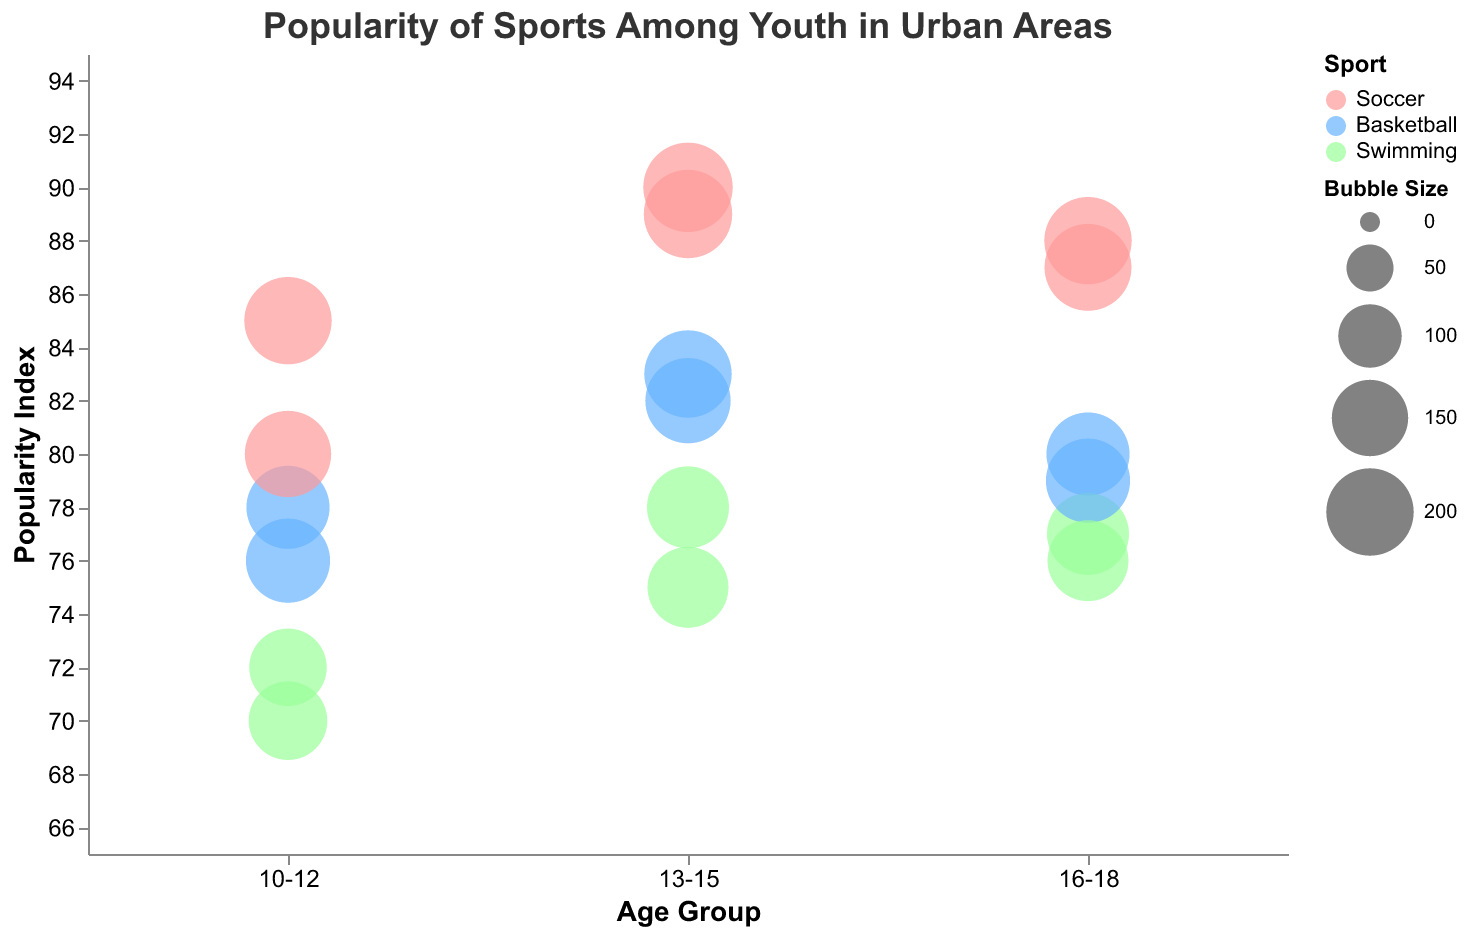How many different age groups are represented in the figure? The x-axis categorizes the data into different age groups. By observing the axis labels, we see three distinct age groups: "10-12", "13-15", and "16-18".
Answer: 3 Which sport has the highest popularity index among the 13-15 age group in Chicago? From the bubbles corresponding to the "13-15" age group and labeled as being in Chicago, we look at the popularity indices. Soccer has a popularity index of 90, which is the highest among the given sports.
Answer: Soccer What is the average popularity index of swimming across all age groups and urban areas? The popularity indices for swimming are 70, 75, 77, 72, 78, and 76. Summing these up, we get 448. Dividing by the total number of data points (6), we obtain 448/6.
Answer: 74.67 Which sport appears to be most popular across all the urban areas for the age group 16-18 based on the popularity index? Looking at the 16-18 age group, we compare the popularity indices of Soccer (88, 87), Basketball (80, 79), and Swimming (77, 76). Soccer has the highest average popularity.
Answer: Soccer In which urban area is the popularity index of Basketball highest for the age group 10-12? By examining the "10-12" age group and filtering for Basketball, we find popularity indices in New York (78) and San Francisco (76). The highest value is in New York.
Answer: New York Which sport's popularity index shows the greatest increase from the age group 10-12 to 13-15? We compare the increase in popularity index for Soccer, Basketball, and Swimming from the "10-12" to the "13-15" age group. Soccer goes from a max of 85 to 90 (increase of 5), Basketball from 78 to 83 (increase of 5), and Swimming from 70 to 78 (increase of 8). Swimming shows the greatest increase.
Answer: Swimming What is the total bubble size for Soccer across all age groups and urban areas? The bubble sizes for Soccer are 200, 210, 200, 195, 205, and 198. Summing these gives 1208.
Answer: 1208 How does the popularity index of Basketball in Miami for the age group 16-18 compare to Swimming in the same city and age group? For the age group 16-18 in Miami, Basketball has a popularity index of 80 and Swimming is labeled as being in a different city (Atlanta). Hence, Basketball in Miami doesn't have a direct comparison but higher than the related Swimming index of 77.
Answer: Higher Which urban area has the greatest overall popularity index for Soccer? For each urban area, we need to identify the Soccer popularity index values and compare. Chicago (90) has the highest value mentioned.
Answer: Chicago What is the difference in popularity index between the most popular and least popular sport in the 13-15 age group? The most popular sport (Soccer: 90) and the least popular (Swimming: 75) in the 13-15 age group show a difference of 90 - 75.
Answer: 15 